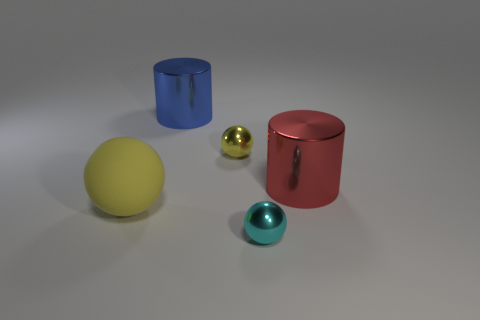Add 1 small yellow spheres. How many objects exist? 6 Subtract all metal spheres. How many spheres are left? 1 Subtract all yellow balls. How many balls are left? 1 Subtract 1 cylinders. How many cylinders are left? 1 Subtract all gray balls. Subtract all green cubes. How many balls are left? 3 Subtract all brown cylinders. How many purple balls are left? 0 Subtract all red cylinders. Subtract all metallic cylinders. How many objects are left? 2 Add 5 cyan balls. How many cyan balls are left? 6 Add 4 tiny cyan balls. How many tiny cyan balls exist? 5 Subtract 0 gray blocks. How many objects are left? 5 